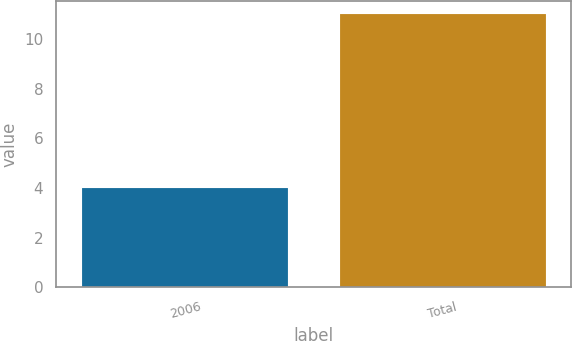<chart> <loc_0><loc_0><loc_500><loc_500><bar_chart><fcel>2006<fcel>Total<nl><fcel>4<fcel>11<nl></chart> 